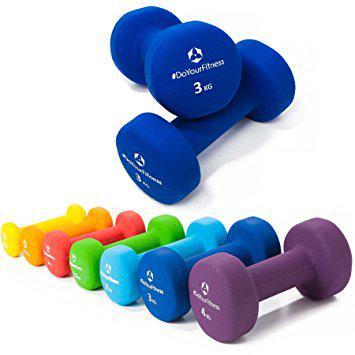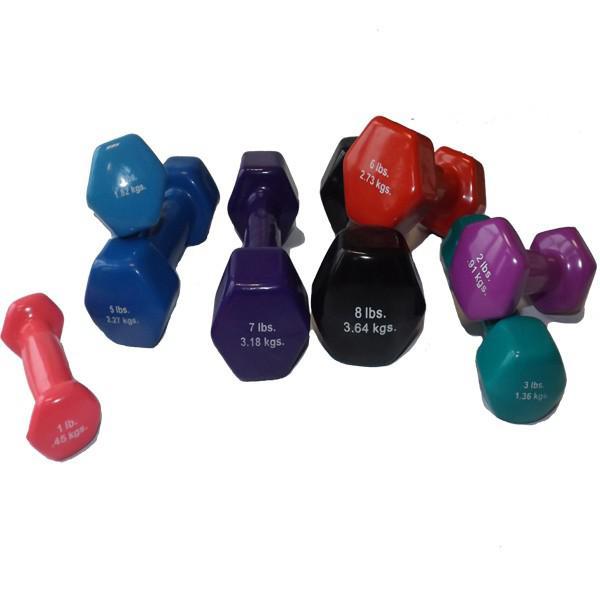The first image is the image on the left, the second image is the image on the right. Assess this claim about the two images: "All of the weights in the image on the right are completely blue in color.". Correct or not? Answer yes or no. No. 